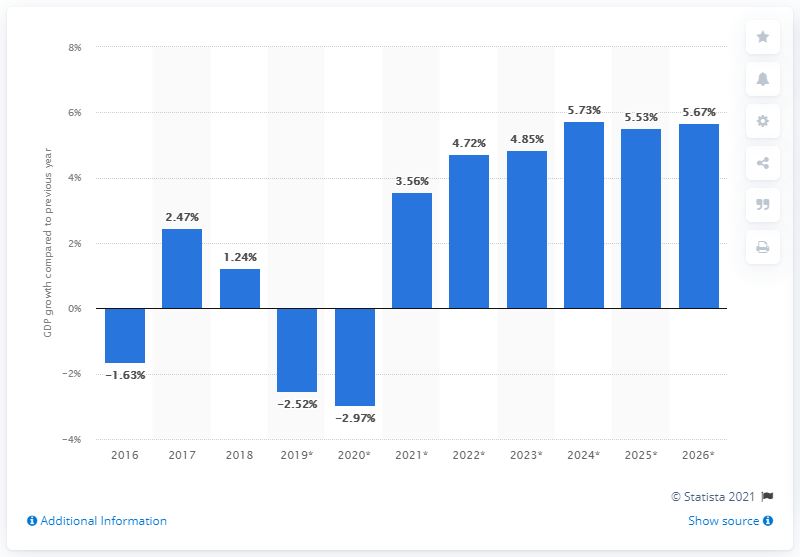Identify some key points in this picture. Liberia's Gross Domestic Product (GDP) grew by 1.24% in 2018. 